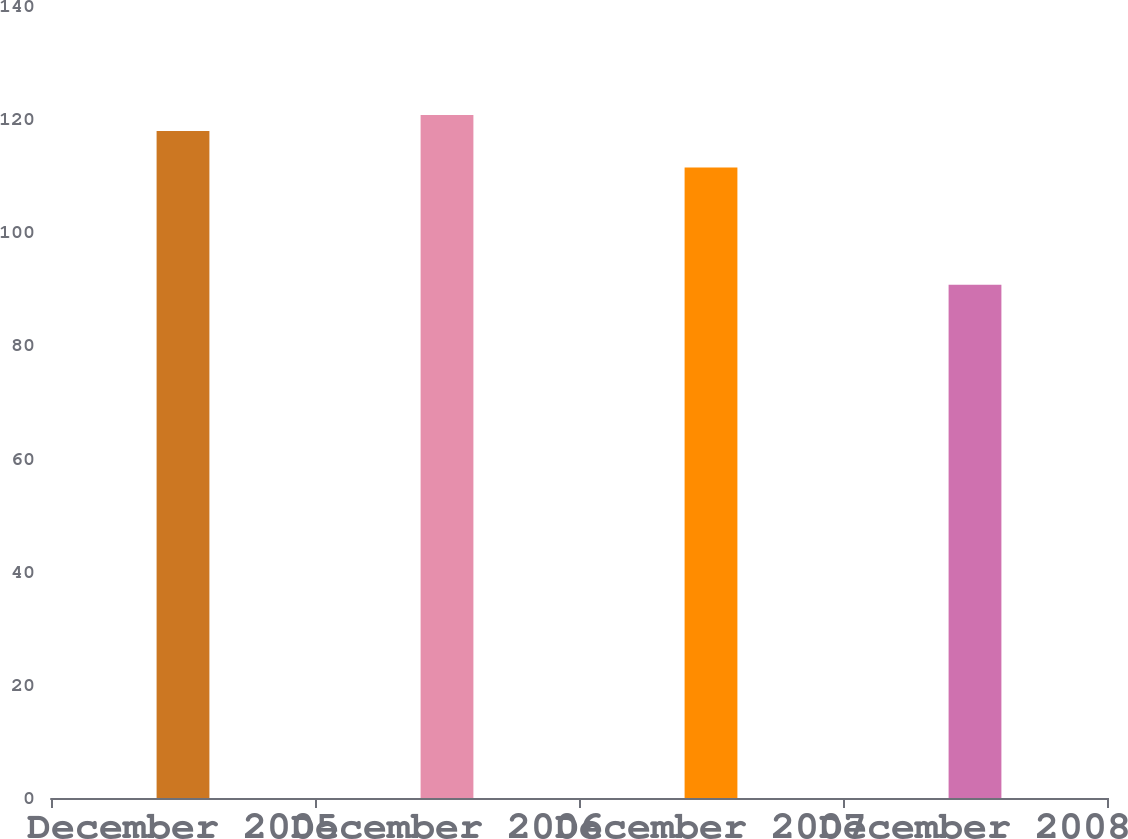<chart> <loc_0><loc_0><loc_500><loc_500><bar_chart><fcel>December 2005<fcel>December 2006<fcel>December 2007<fcel>December 2008<nl><fcel>117.92<fcel>120.75<fcel>111.44<fcel>90.73<nl></chart> 